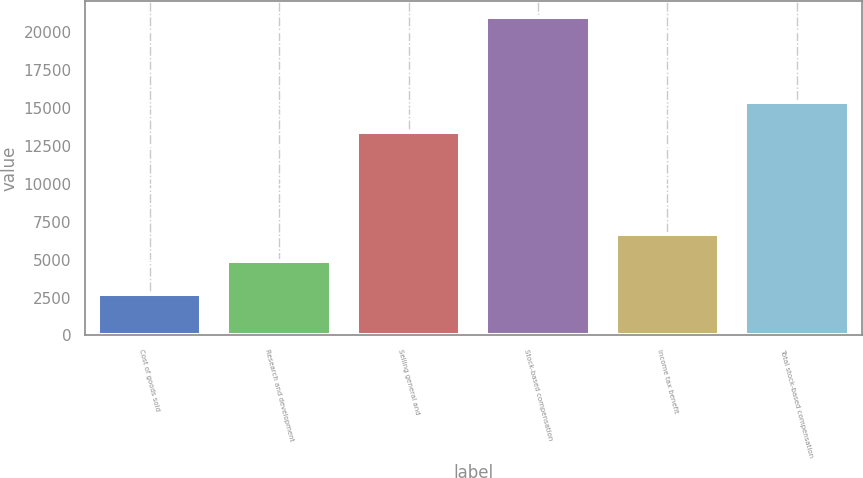Convert chart. <chart><loc_0><loc_0><loc_500><loc_500><bar_chart><fcel>Cost of goods sold<fcel>Research and development<fcel>Selling general and<fcel>Stock-based compensation<fcel>Income tax benefit<fcel>Total stock-based compensation<nl><fcel>2721<fcel>4882<fcel>13371<fcel>20974<fcel>6707.3<fcel>15385<nl></chart> 